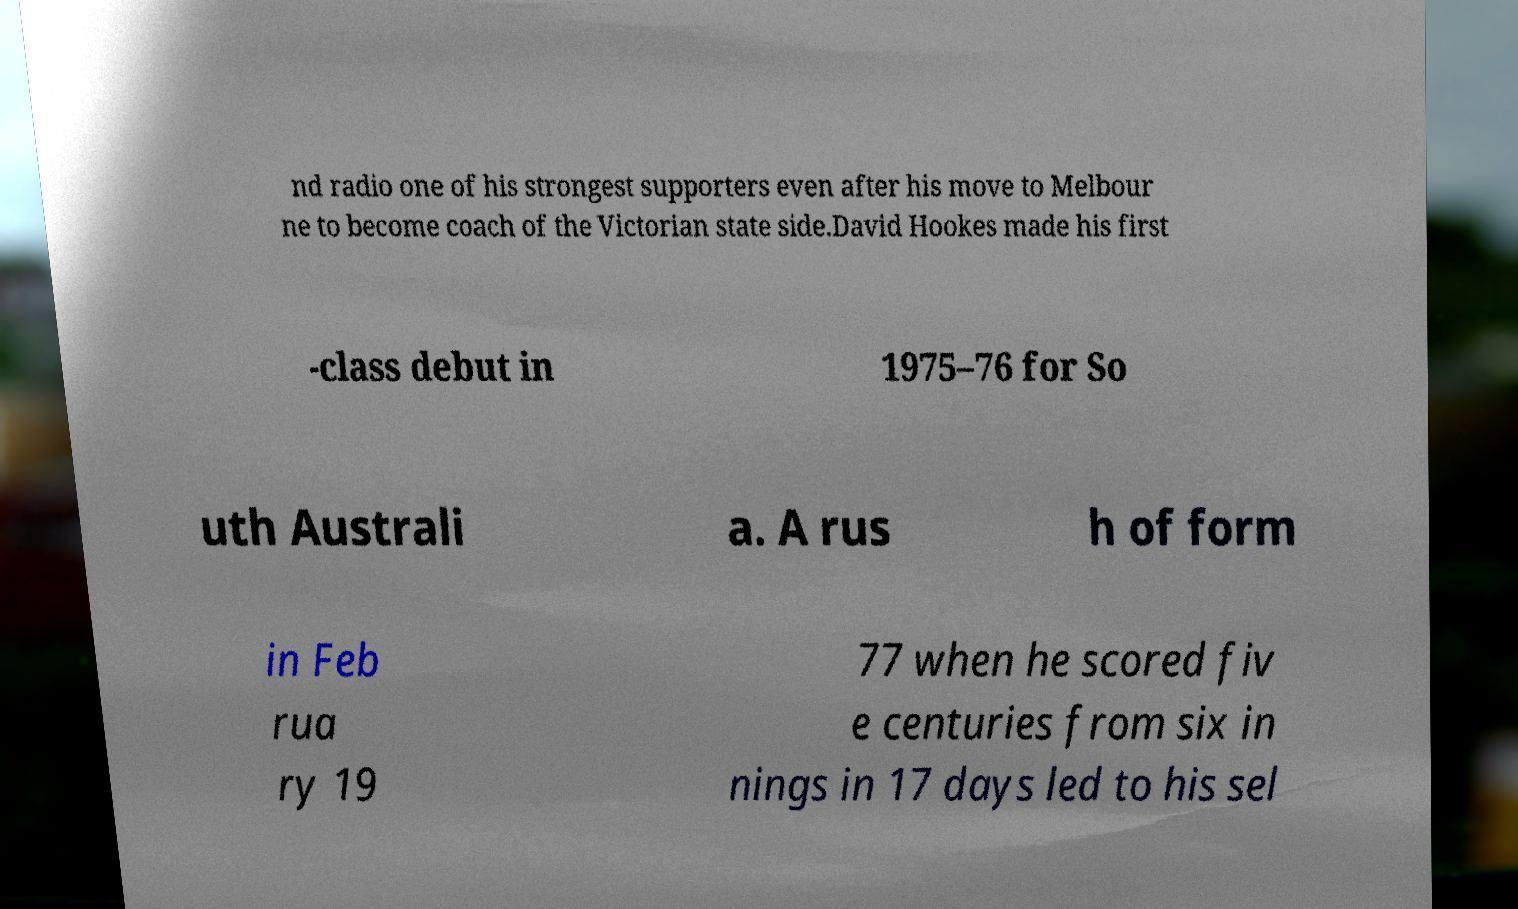For documentation purposes, I need the text within this image transcribed. Could you provide that? nd radio one of his strongest supporters even after his move to Melbour ne to become coach of the Victorian state side.David Hookes made his first -class debut in 1975–76 for So uth Australi a. A rus h of form in Feb rua ry 19 77 when he scored fiv e centuries from six in nings in 17 days led to his sel 